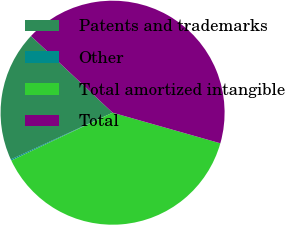Convert chart. <chart><loc_0><loc_0><loc_500><loc_500><pie_chart><fcel>Patents and trademarks<fcel>Other<fcel>Total amortized intangible<fcel>Total<nl><fcel>18.86%<fcel>0.17%<fcel>38.57%<fcel>42.4%<nl></chart> 